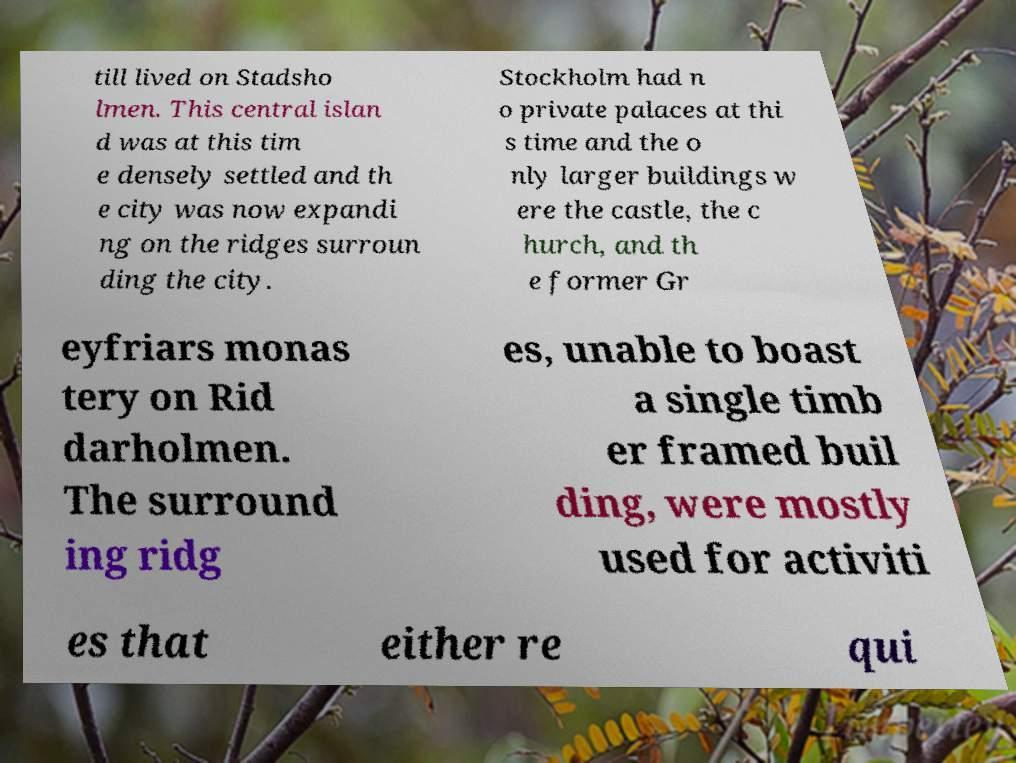For documentation purposes, I need the text within this image transcribed. Could you provide that? till lived on Stadsho lmen. This central islan d was at this tim e densely settled and th e city was now expandi ng on the ridges surroun ding the city. Stockholm had n o private palaces at thi s time and the o nly larger buildings w ere the castle, the c hurch, and th e former Gr eyfriars monas tery on Rid darholmen. The surround ing ridg es, unable to boast a single timb er framed buil ding, were mostly used for activiti es that either re qui 